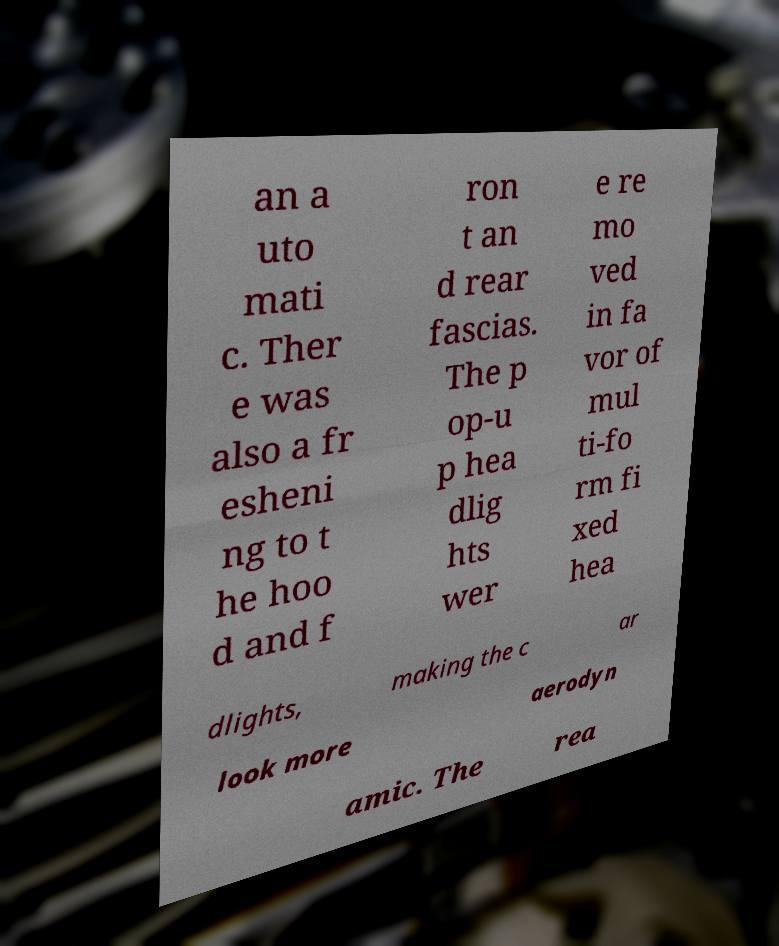Could you extract and type out the text from this image? an a uto mati c. Ther e was also a fr esheni ng to t he hoo d and f ron t an d rear fascias. The p op-u p hea dlig hts wer e re mo ved in fa vor of mul ti-fo rm fi xed hea dlights, making the c ar look more aerodyn amic. The rea 